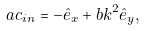Convert formula to latex. <formula><loc_0><loc_0><loc_500><loc_500>\ a c _ { i n } = - \hat { e } _ { x } + b k ^ { 2 } \hat { e } _ { y } ,</formula> 